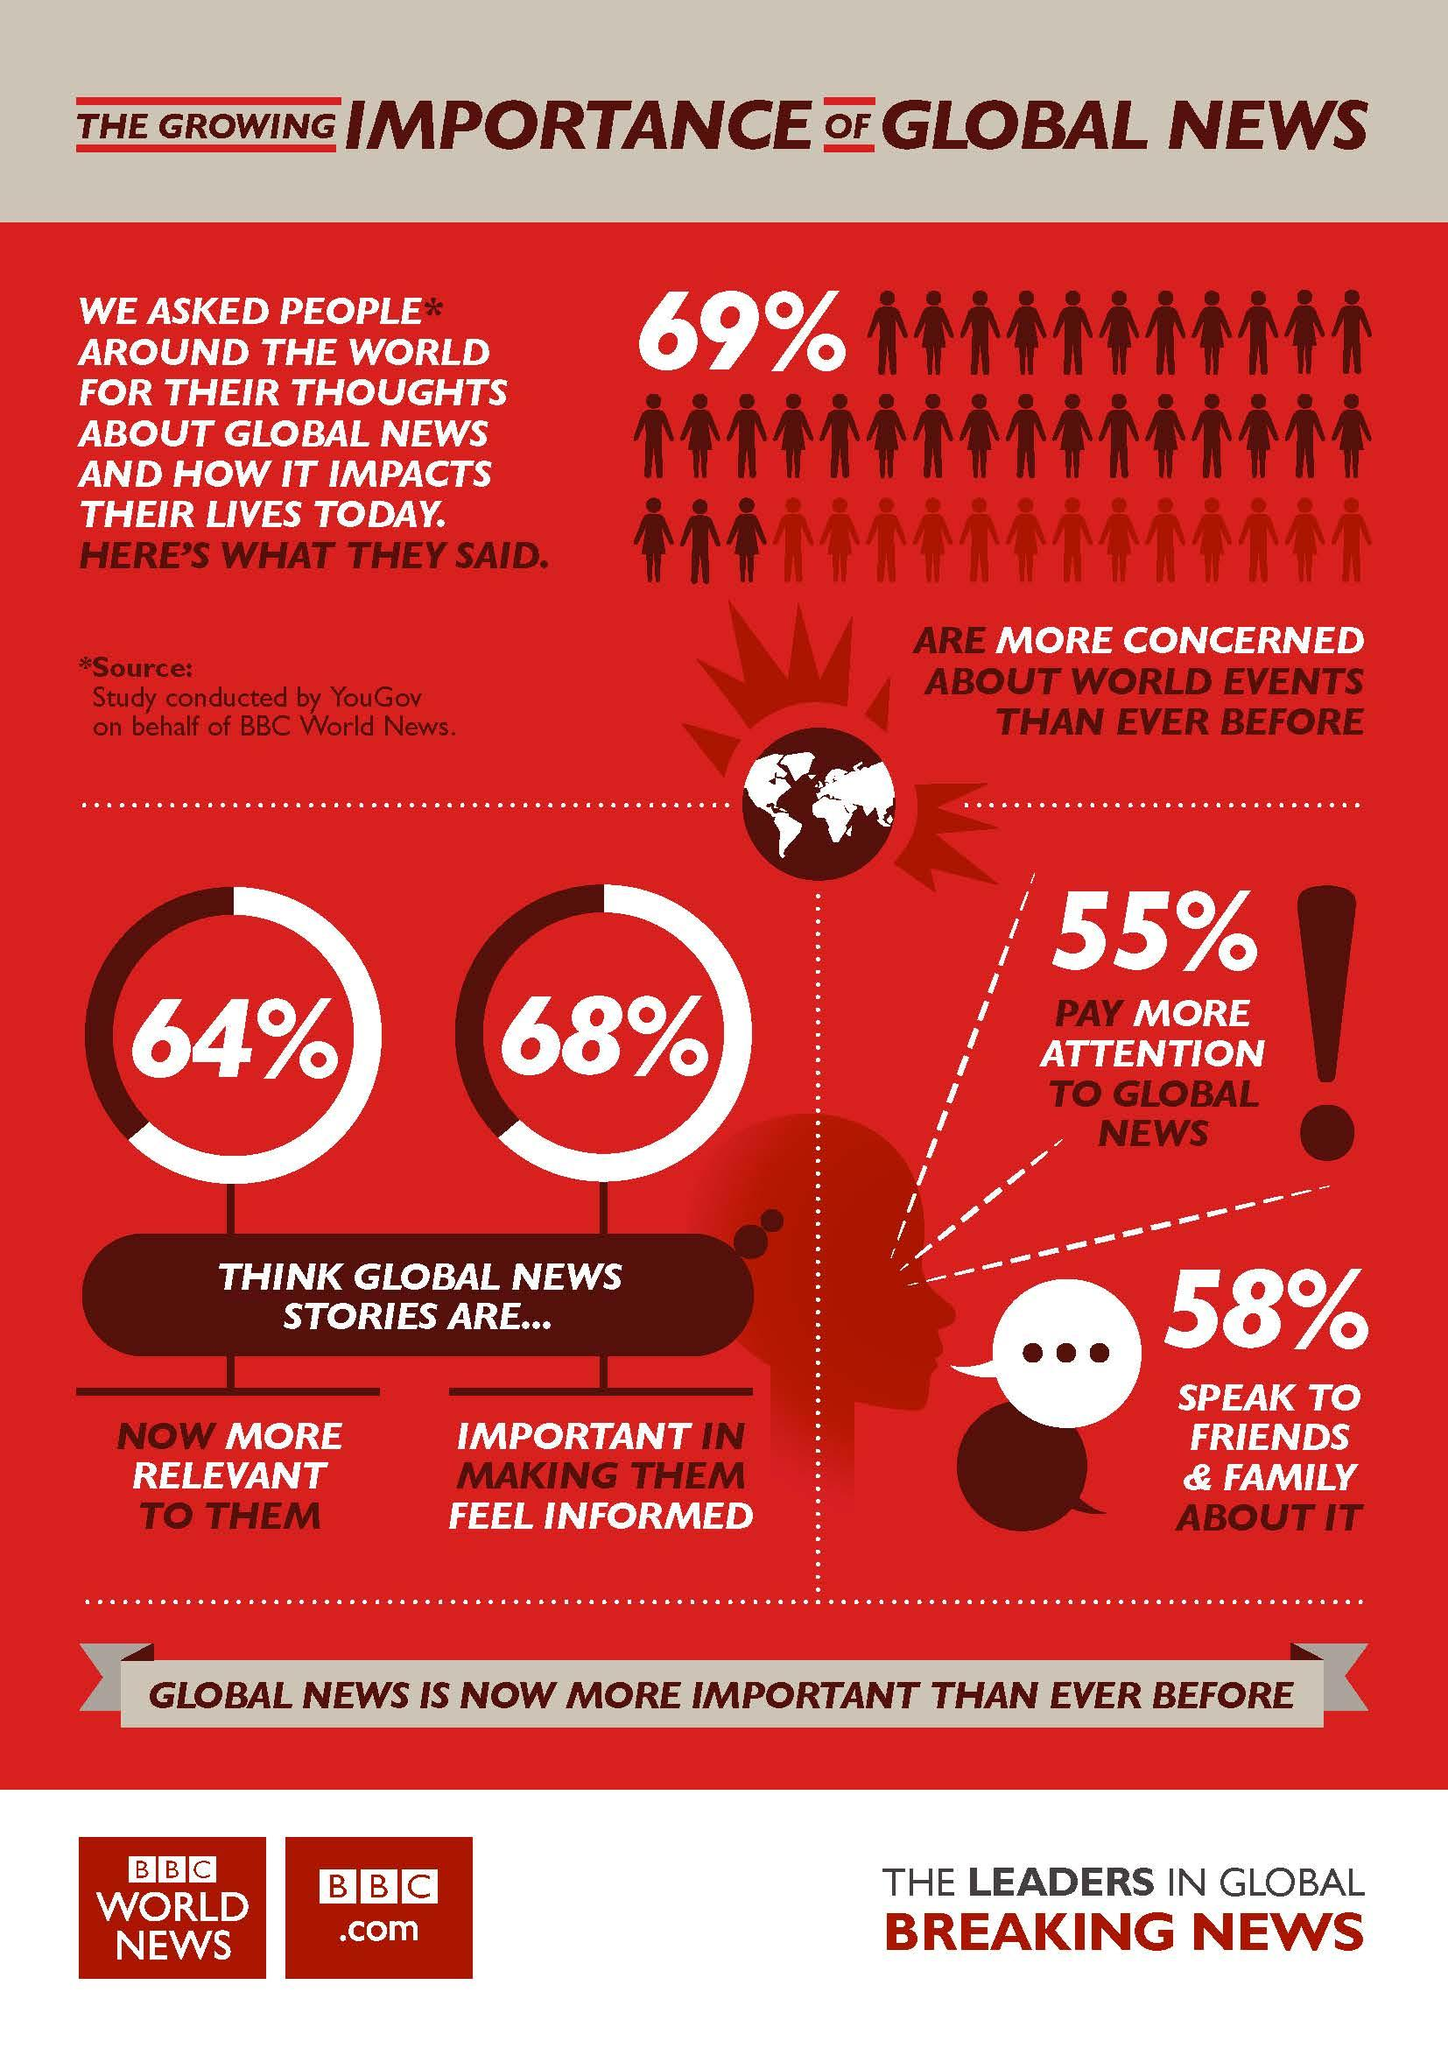Highlight a few significant elements in this photo. According to a study conducted by YouGov on behalf of BBC World News, 68% of people believe that global news stories are important in making them feel informed. According to a study conducted by YouGov on behalf of BBC World News, 45% of people do not pay more attention to global news. 